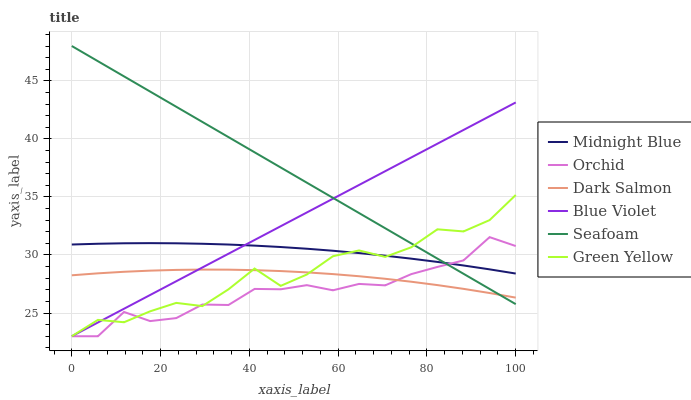Does Orchid have the minimum area under the curve?
Answer yes or no. Yes. Does Seafoam have the maximum area under the curve?
Answer yes or no. Yes. Does Dark Salmon have the minimum area under the curve?
Answer yes or no. No. Does Dark Salmon have the maximum area under the curve?
Answer yes or no. No. Is Blue Violet the smoothest?
Answer yes or no. Yes. Is Green Yellow the roughest?
Answer yes or no. Yes. Is Seafoam the smoothest?
Answer yes or no. No. Is Seafoam the roughest?
Answer yes or no. No. Does Green Yellow have the lowest value?
Answer yes or no. Yes. Does Seafoam have the lowest value?
Answer yes or no. No. Does Seafoam have the highest value?
Answer yes or no. Yes. Does Dark Salmon have the highest value?
Answer yes or no. No. Is Dark Salmon less than Midnight Blue?
Answer yes or no. Yes. Is Midnight Blue greater than Dark Salmon?
Answer yes or no. Yes. Does Blue Violet intersect Orchid?
Answer yes or no. Yes. Is Blue Violet less than Orchid?
Answer yes or no. No. Is Blue Violet greater than Orchid?
Answer yes or no. No. Does Dark Salmon intersect Midnight Blue?
Answer yes or no. No. 